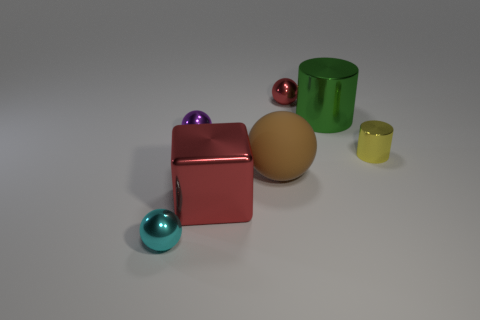Assuming these objects are used for size and volume comparison, can you estimate their dimensions relative to each other? Based on their appearance, the large green cylinder seems to be the tallest object, followed by the large beige sphere. The small yellow cylinder and the small spheres appear approximately the same in size but smaller in volume compared to the large objects. The small red cube is similar in dimension to the small spheres but with a different shape. 